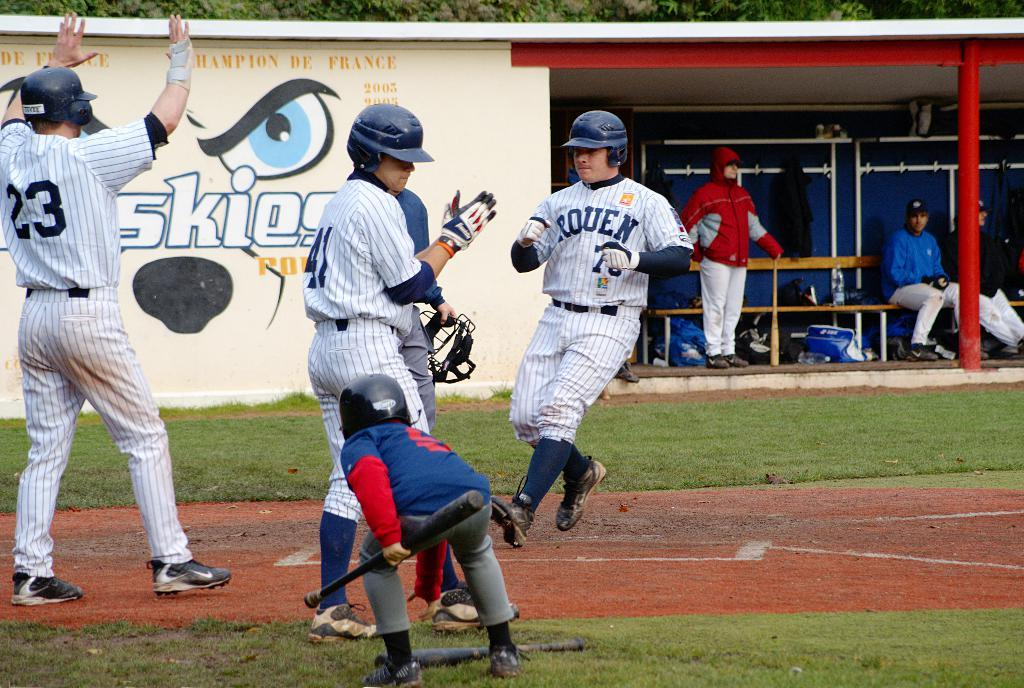<image>
Write a terse but informative summary of the picture. The Rouen baseball player just scored a run. 